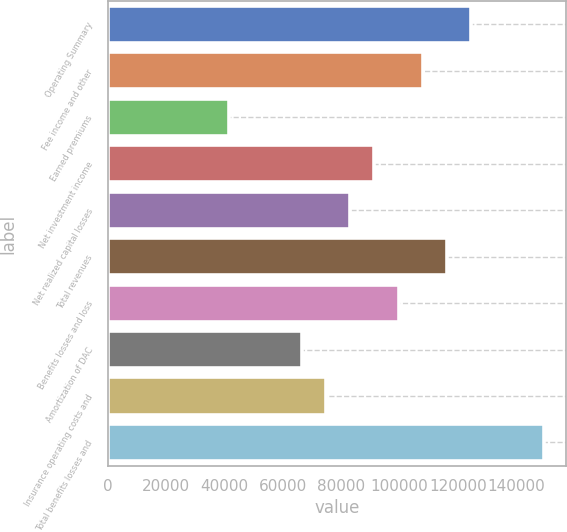Convert chart. <chart><loc_0><loc_0><loc_500><loc_500><bar_chart><fcel>Operating Summary<fcel>Fee income and other<fcel>Earned premiums<fcel>Net investment income<fcel>Net realized capital losses<fcel>Total revenues<fcel>Benefits losses and loss<fcel>Amortization of DAC<fcel>Insurance operating costs and<fcel>Total benefits losses and<nl><fcel>124514<fcel>107913<fcel>41512.5<fcel>91313.1<fcel>83013<fcel>116213<fcel>99613.2<fcel>66412.8<fcel>74712.9<fcel>149414<nl></chart> 